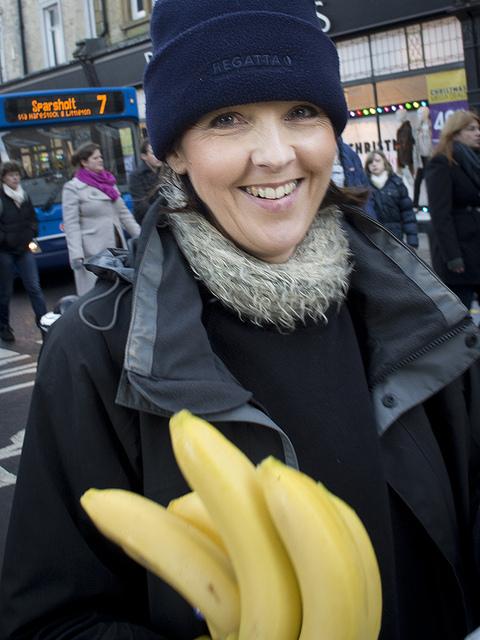What number is lit up on the bus?
Answer briefly. 7. Is this person outside?
Quick response, please. Yes. Is she smiling at the photographer?
Write a very short answer. Yes. What color is her coat?
Short answer required. Black. How many bananas is she holding?
Quick response, please. 5. Is the banana ripe?
Quick response, please. Yes. Is the fruit ripe?
Keep it brief. Yes. 